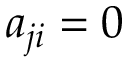Convert formula to latex. <formula><loc_0><loc_0><loc_500><loc_500>a _ { j i } = 0</formula> 